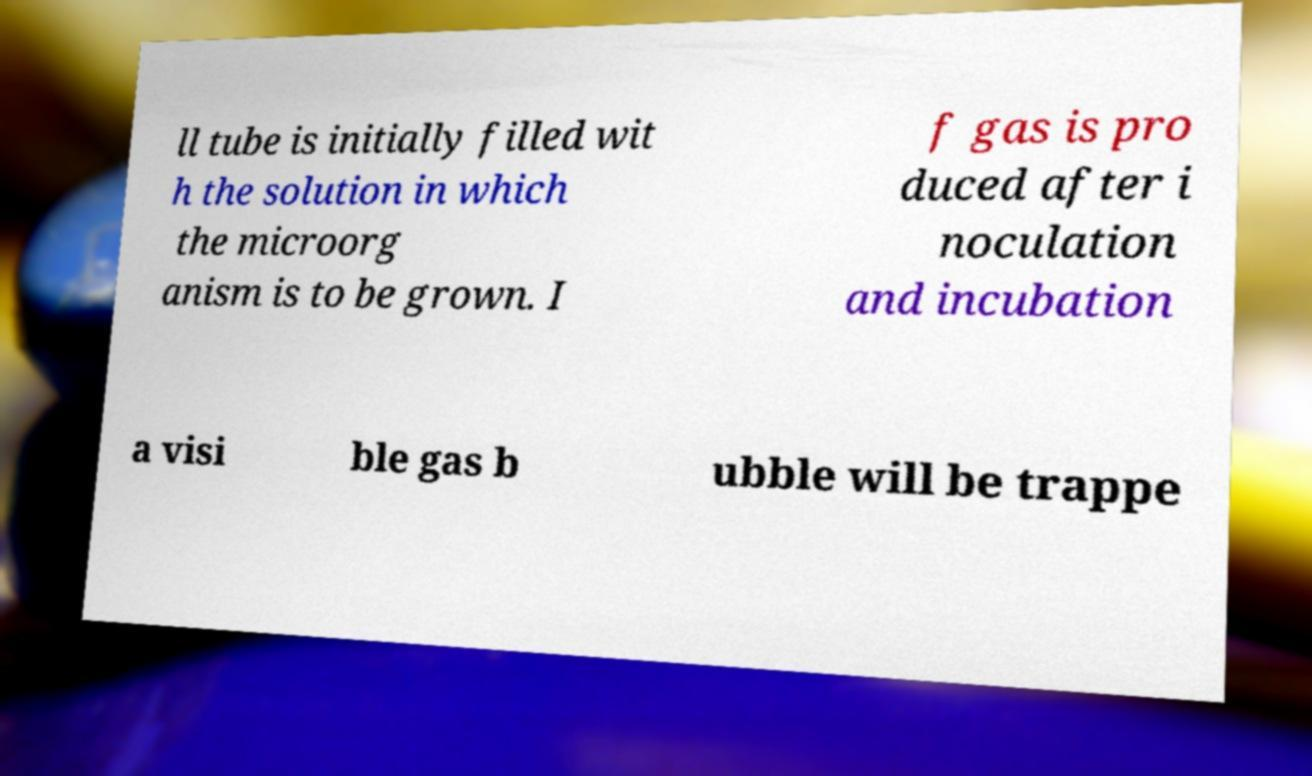There's text embedded in this image that I need extracted. Can you transcribe it verbatim? ll tube is initially filled wit h the solution in which the microorg anism is to be grown. I f gas is pro duced after i noculation and incubation a visi ble gas b ubble will be trappe 